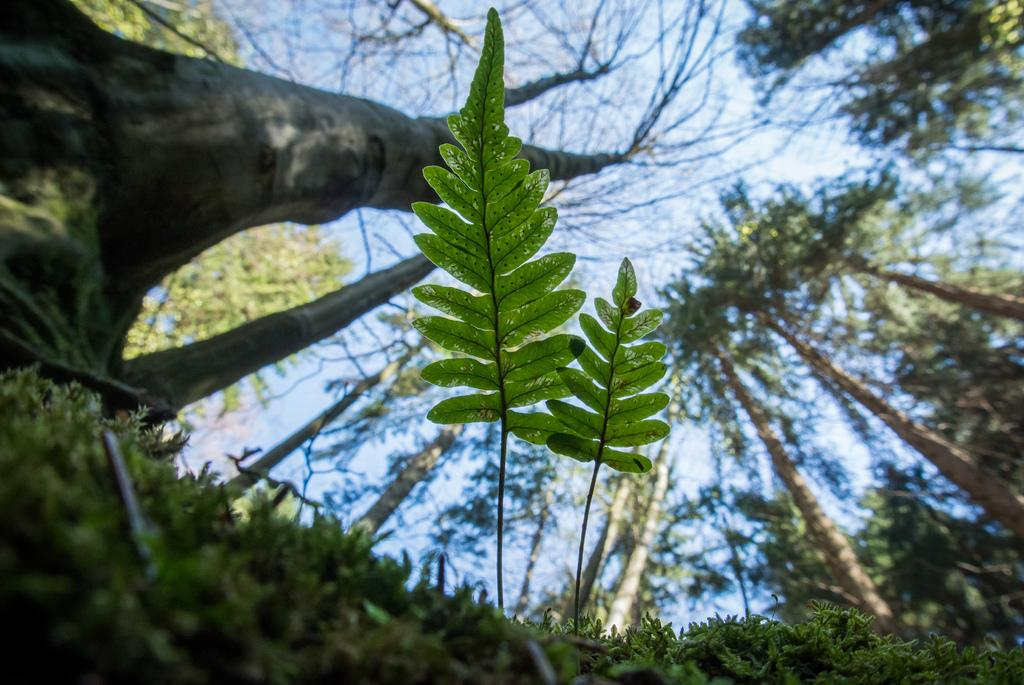What type of vegetation is at the bottom of the image? There is grass at the bottom of the image. What other natural elements can be seen in the image? There are leaves and many trees in the image. What is visible in the background of the image? The sky is visible in the background of the image. Where is the kettle located in the image? There is no kettle present in the image. What type of light source is illuminating the image? The provided facts do not mention any light source; we can only see the natural light from the sky. 